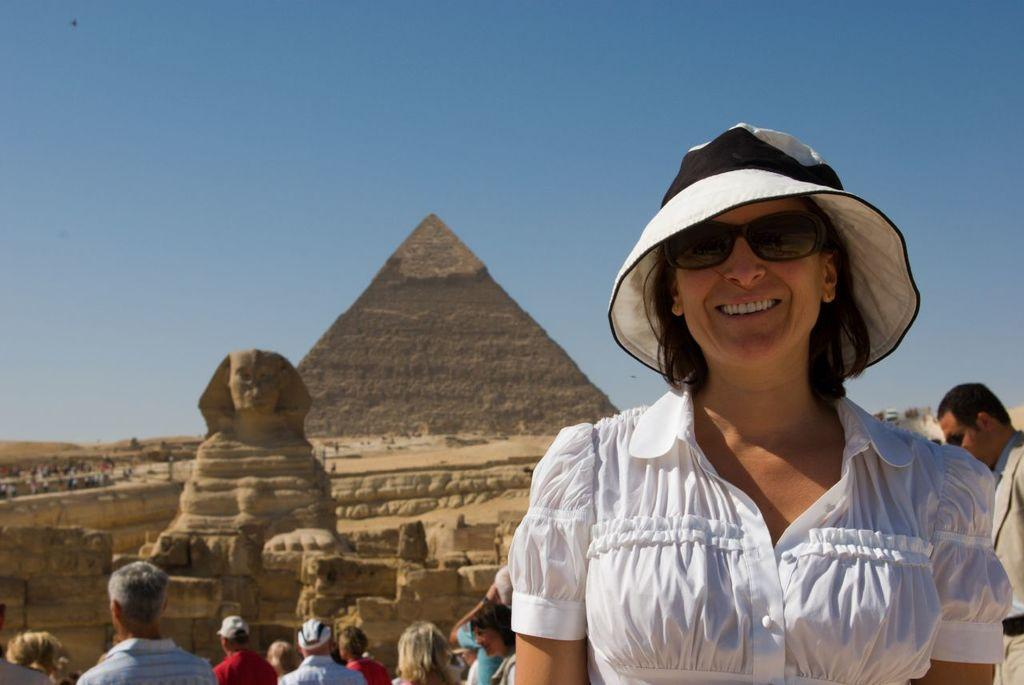What can be seen in the background of the image? In the background of the image, there is a sky, a pyramid, a sculpture, and a wall. What type of structure is visible in the background? The pyramid is visible in the background of the image. What else is present in the background of the image? There is also a sculpture in the background. What is the condition of the sky in the image? The sky is visible in the background of the image. Can you describe the people in the image? There are people in the image, including a woman who is wearing goggles and a hat. What expression does the woman have? The woman is smiling. What type of rose is the woman holding in the image? There is no rose present in the image; the woman is wearing goggles and a hat. What is the woman reading in the image? There is no reading material present in the image; the woman is wearing goggles and a hat. 